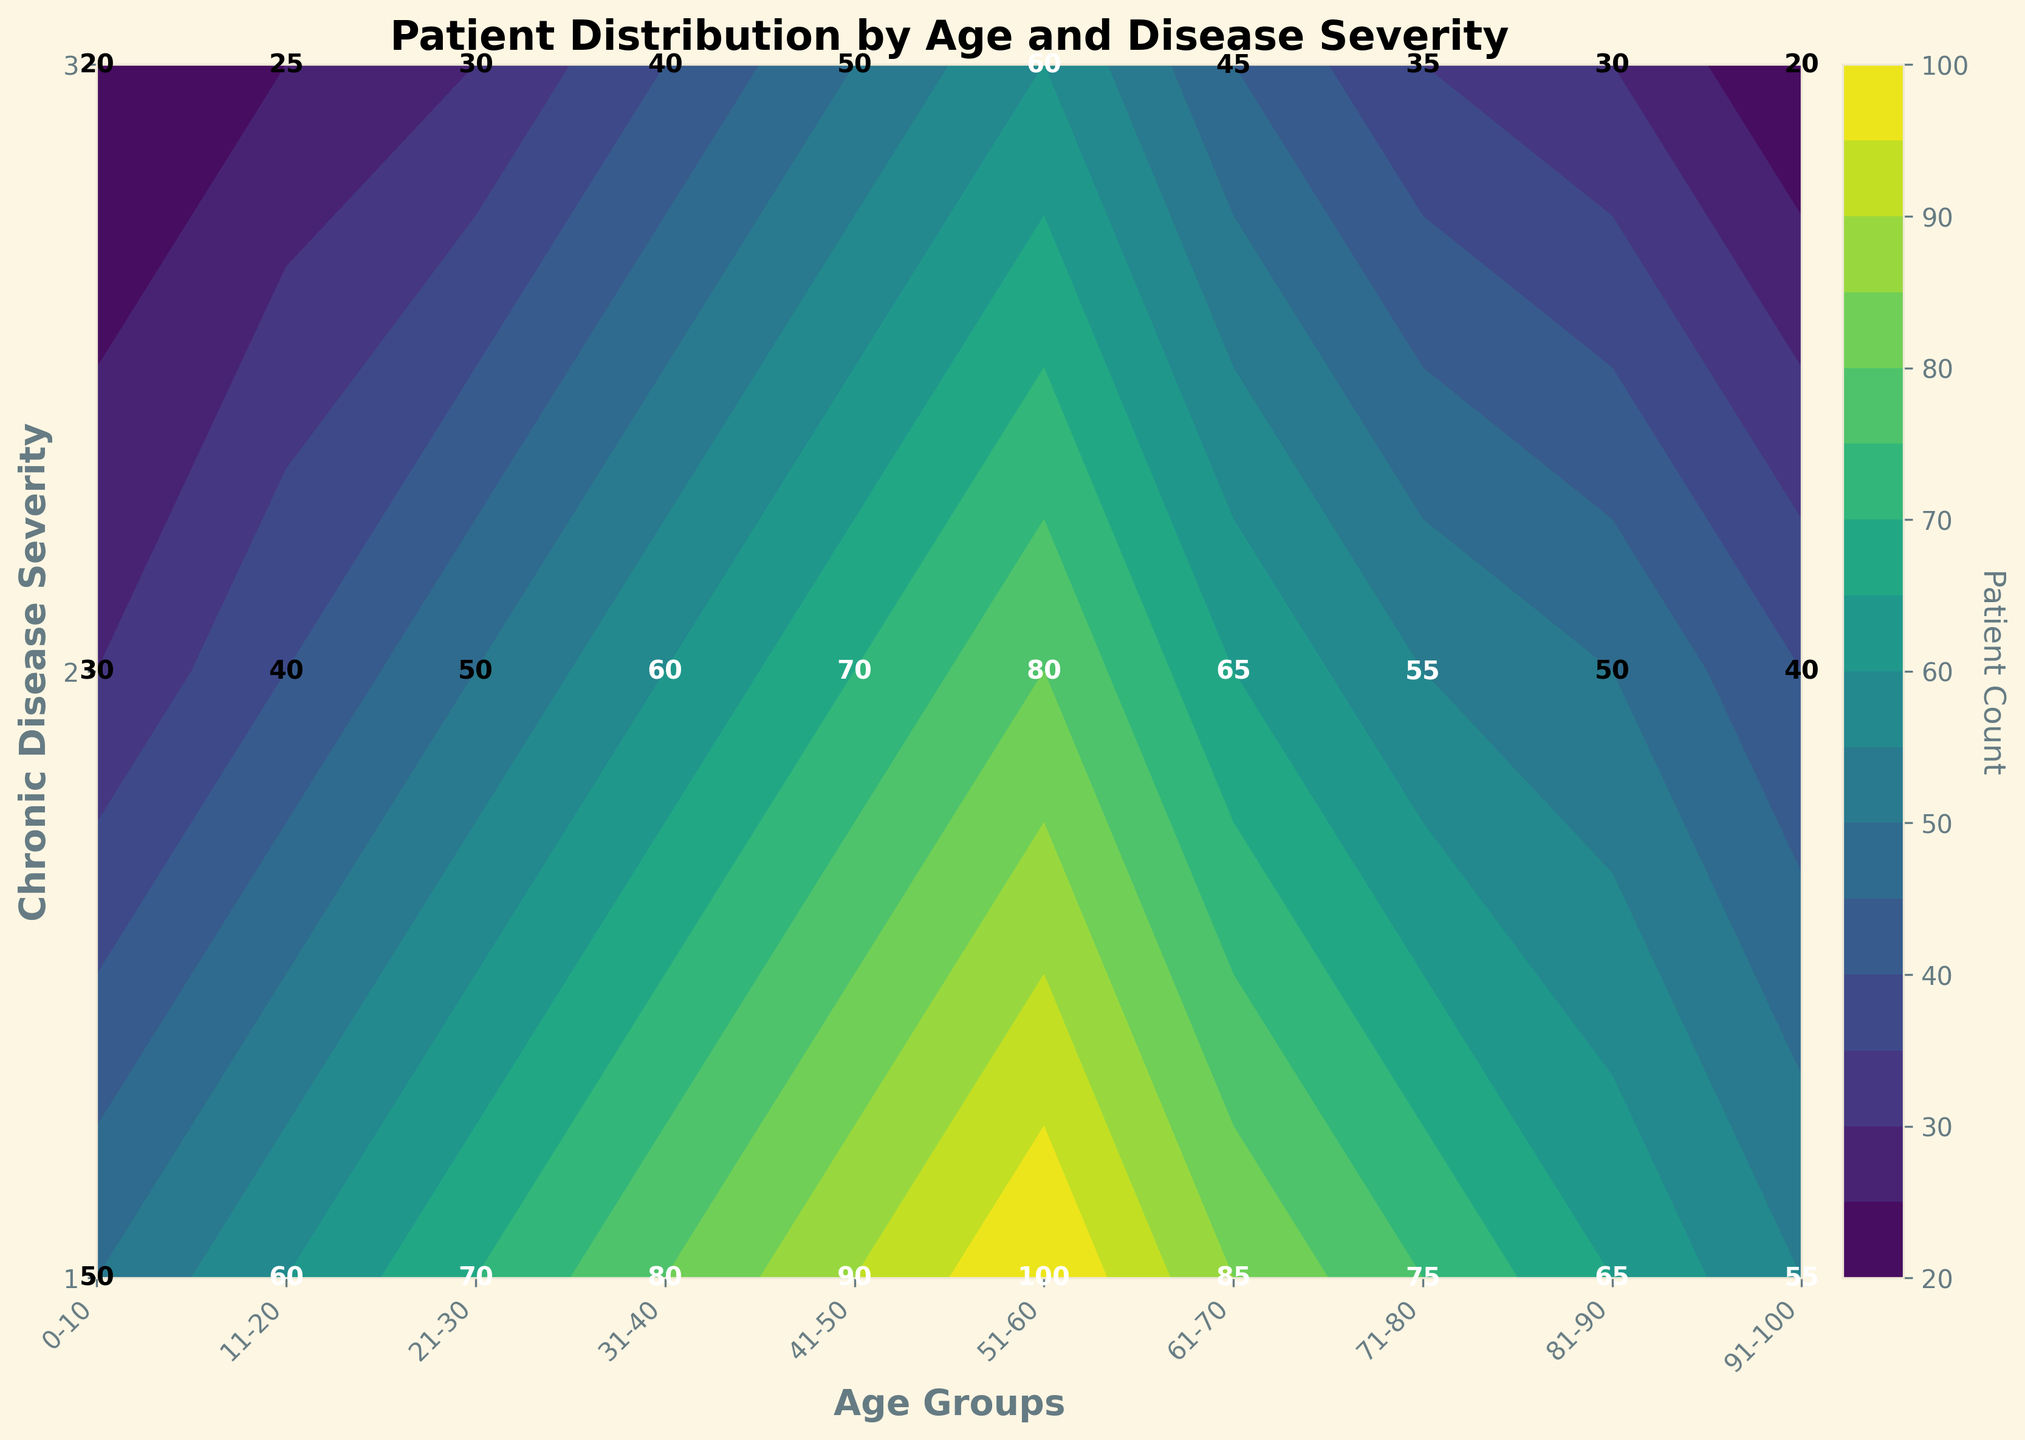Which age group has the highest patient count with the most severe chronic disease level? Locate the age group with the highest contour value at the highest severity level, which is '3', showing the number directly on the plot.
Answer: 51-60 What is the patient count for the age group 31-40 with a chronic disease severity level of 2? Find the intersection of the age group '31-40' and severity level '2' on the plot, and read the value from the annotation.
Answer: 60 How does the patient count for ages 21-30 with severity level 1 compare to that of ages 41-50 with the same severity level? Compare the contour values at the intersection of age '21-30' and severity '1' with age '41-50' and severity '1'. The annotations say '70' and '90' respectively.
Answer: 41-50 has more patients What is the difference in patient counts between the age groups 61-70 and 71-80 for severity level 3? Read the values from the annotations for contour intersections: '61-70' with severity '3' is '45' and '71-80' with severity '3' is '35'. Calculate the difference: 45 - 35.
Answer: 10 What trends can you observe in the patient count as the age increases for severity level 1? Observe the values at intersection points for severity level '1' and note any increases or decreases as age increases from '0-10' to '91-100'. The values increase from ’50’ to ‘100’ till ages 51-60 and then start to decrease.
Answer: Increasing then decreasing Which chronic disease severity level has the highest total patient count in age group 81-90? Sum the patient counts for severity levels '1', '2', and '3' within '81-90': 65 + 50 + 30 = 145.
Answer: 1 How does the patient count for ages 0-10 with severity level 2 compare to the next age group with the same severity level? Read the values from the annotations for contour intersections: '0-10' with severity level '2' shows '30', and '11-20' is '40'.
Answer: 11-20 has more patients What is the overall trend in patient counts across all age groups for severity level 2? Observe the intersection points for severity level '2' across all age groups. The values show a generally increasing trend until 51-60 and then start to decrease.
Answer: Increase then decrease 